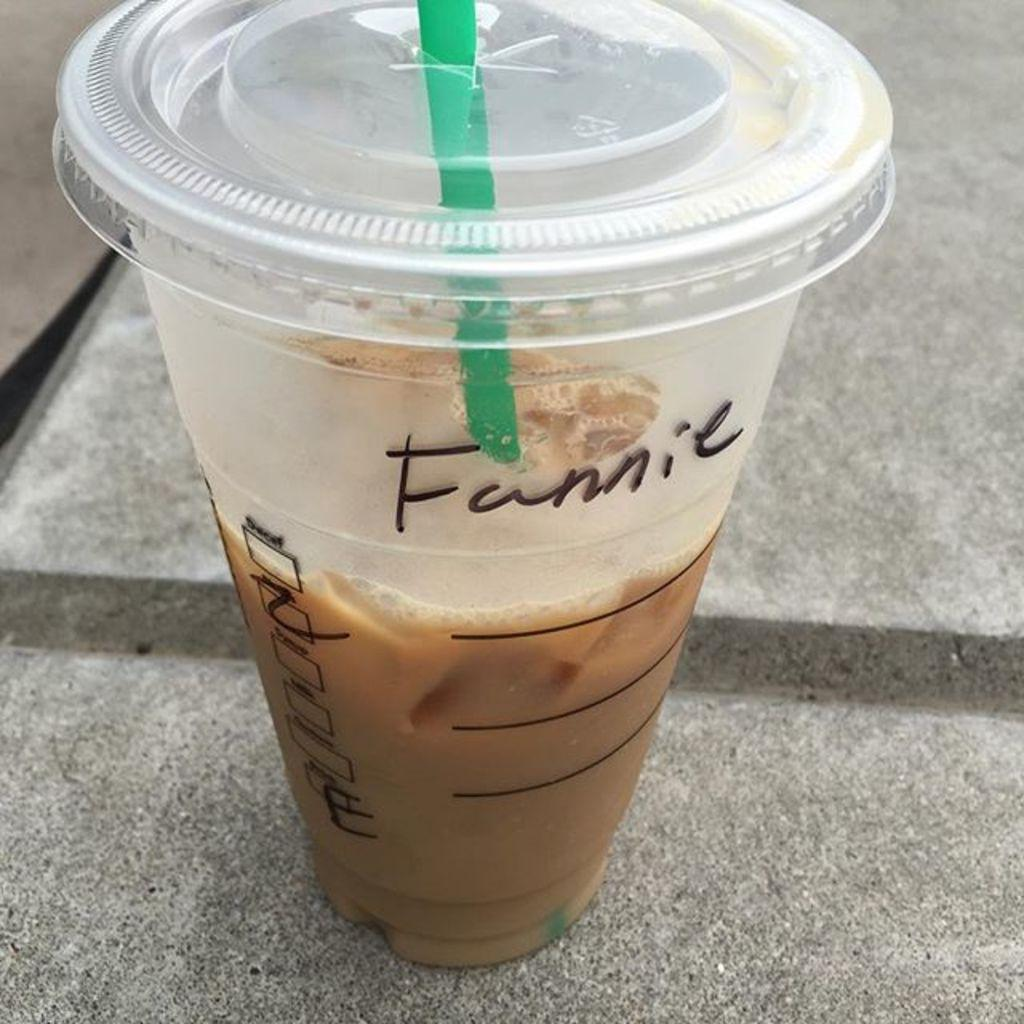What is in the glass that is visible in the image? There is a glass of drink in the image. What is used to drink the liquid in the glass? There is a straw in the glass. What can be seen on the glass besides the drink and straw? There is text on the glass. What type of horn is being used to play music in the image? There is no horn present in the image; it only features a glass of drink with a straw and text on it. 